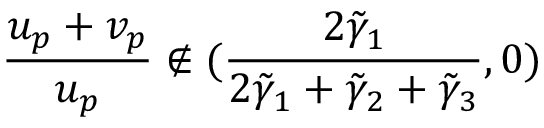Convert formula to latex. <formula><loc_0><loc_0><loc_500><loc_500>\frac { u _ { p } + v _ { p } } { u _ { p } } \notin ( \frac { 2 \tilde { \gamma } _ { 1 } } { 2 \tilde { \gamma } _ { 1 } + \tilde { \gamma } _ { 2 } + \tilde { \gamma } _ { 3 } } , 0 )</formula> 